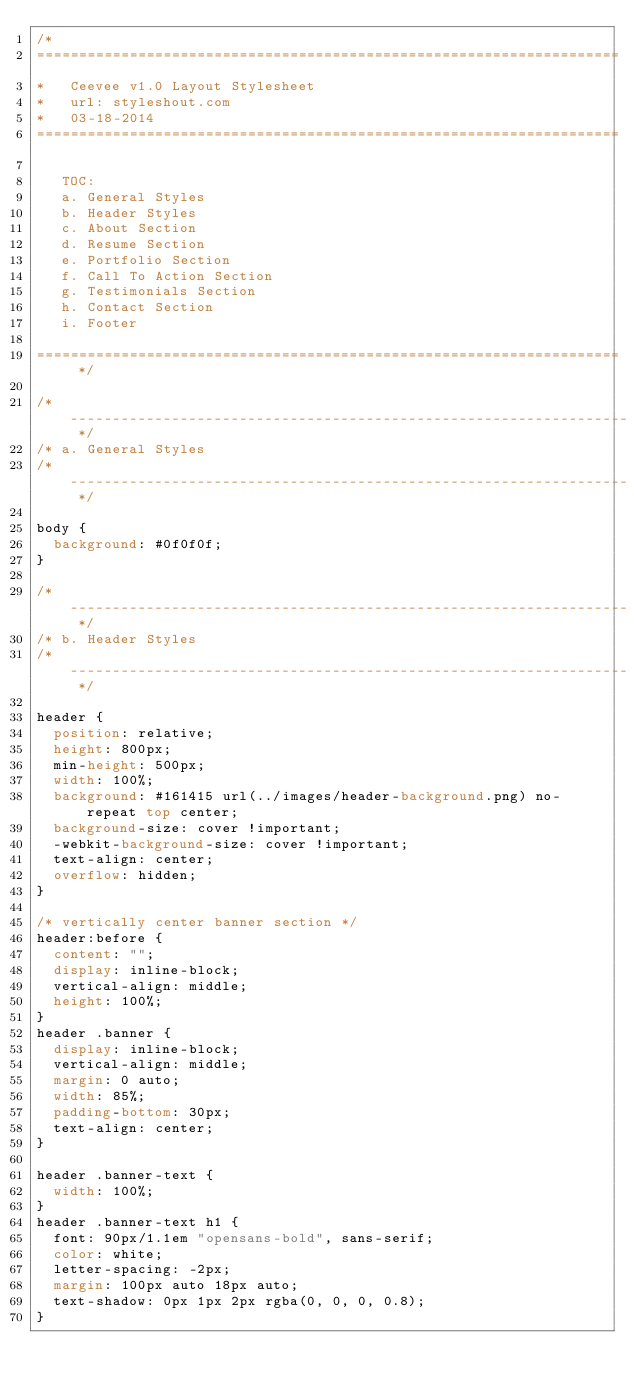<code> <loc_0><loc_0><loc_500><loc_500><_CSS_>/*
=====================================================================
*   Ceevee v1.0 Layout Stylesheet
*   url: styleshout.com
*   03-18-2014
=====================================================================

   TOC:
   a. General Styles
   b. Header Styles
   c. About Section
   d. Resume Section
   e. Portfolio Section
   f. Call To Action Section
   g. Testimonials Section
   h. Contact Section
   i. Footer

===================================================================== */

/* ------------------------------------------------------------------ */
/* a. General Styles
/* ------------------------------------------------------------------ */

body {
  background: #0f0f0f;
}

/* ------------------------------------------------------------------ */
/* b. Header Styles
/* ------------------------------------------------------------------ */

header {
  position: relative;
  height: 800px;
  min-height: 500px;
  width: 100%;
  background: #161415 url(../images/header-background.png) no-repeat top center;
  background-size: cover !important;
  -webkit-background-size: cover !important;
  text-align: center;
  overflow: hidden;
}

/* vertically center banner section */
header:before {
  content: "";
  display: inline-block;
  vertical-align: middle;
  height: 100%;
}
header .banner {
  display: inline-block;
  vertical-align: middle;
  margin: 0 auto;
  width: 85%;
  padding-bottom: 30px;
  text-align: center;
}

header .banner-text {
  width: 100%;
}
header .banner-text h1 {
  font: 90px/1.1em "opensans-bold", sans-serif;
  color: white;
  letter-spacing: -2px;
  margin: 100px auto 18px auto;
  text-shadow: 0px 1px 2px rgba(0, 0, 0, 0.8);
}</code> 